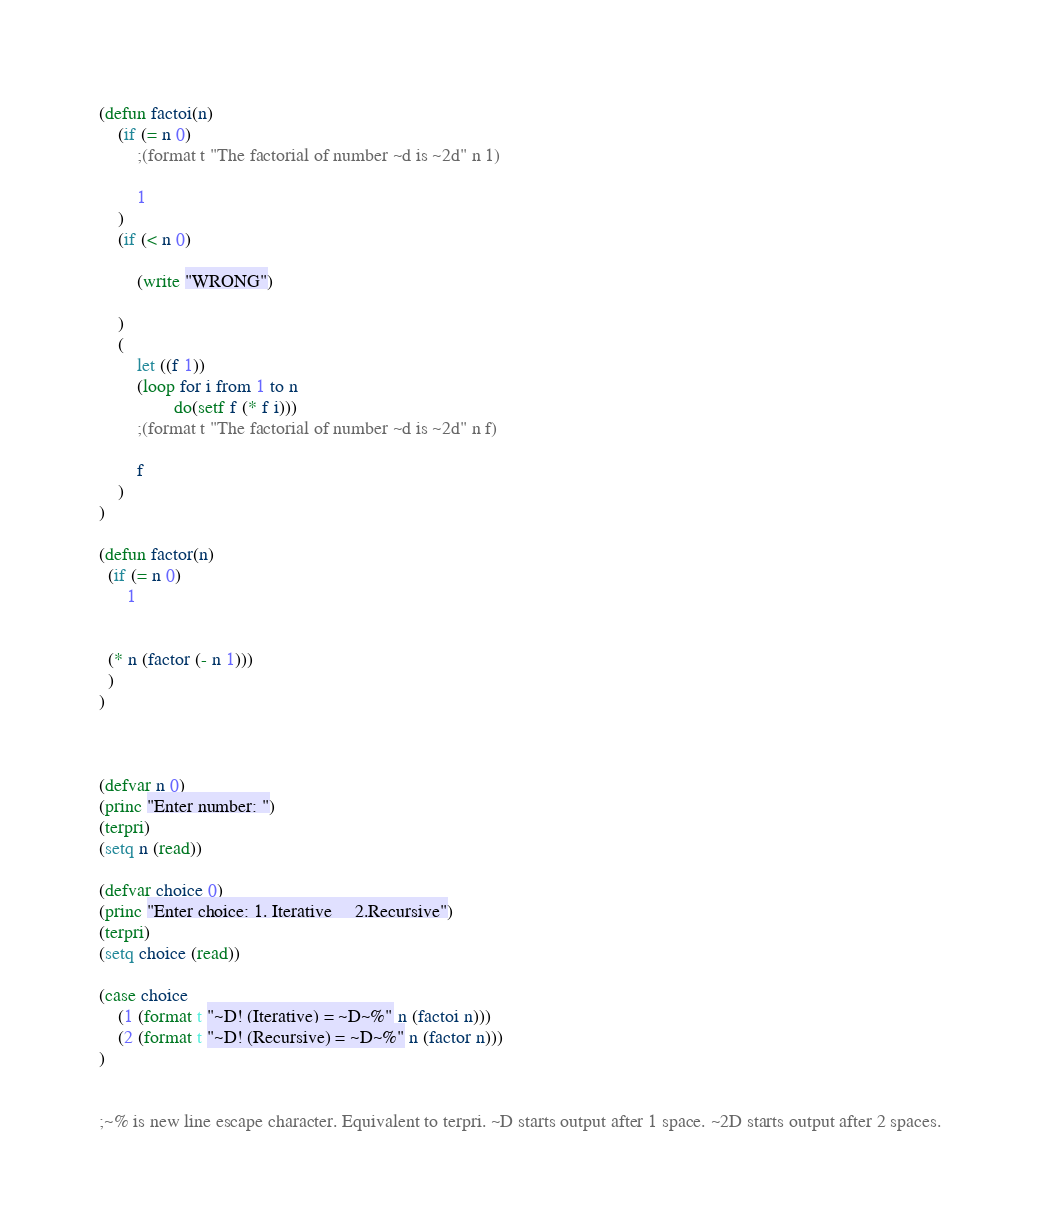<code> <loc_0><loc_0><loc_500><loc_500><_Lisp_>(defun factoi(n)
	(if (= n 0)
		;(format t "The factorial of number ~d is ~2d" n 1)
		
		1
	)
	(if (< n 0)
	
		(write "WRONG")
	
	)	
	(
		let ((f 1))
    	(loop for i from 1 to n
           		do(setf f (* f i)))
    	;(format t "The factorial of number ~d is ~2d" n f) 
    	
    	f
    )
)

(defun factor(n)
  (if (= n 0)
      1
  
  
  (* n (factor (- n 1)))
  )
)



(defvar n 0)
(princ "Enter number: ")
(terpri)
(setq n (read))
 
(defvar choice 0)
(princ "Enter choice: 1. Iterative 	2.Recursive")
(terpri)
(setq choice (read))

(case choice 
	(1 (format t "~D! (Iterative) = ~D~%" n (factoi n)))
	(2 (format t "~D! (Recursive) = ~D~%" n (factor n)))
)


;~% is new line escape character. Equivalent to terpri. ~D starts output after 1 space. ~2D starts output after 2 spaces.
</code> 